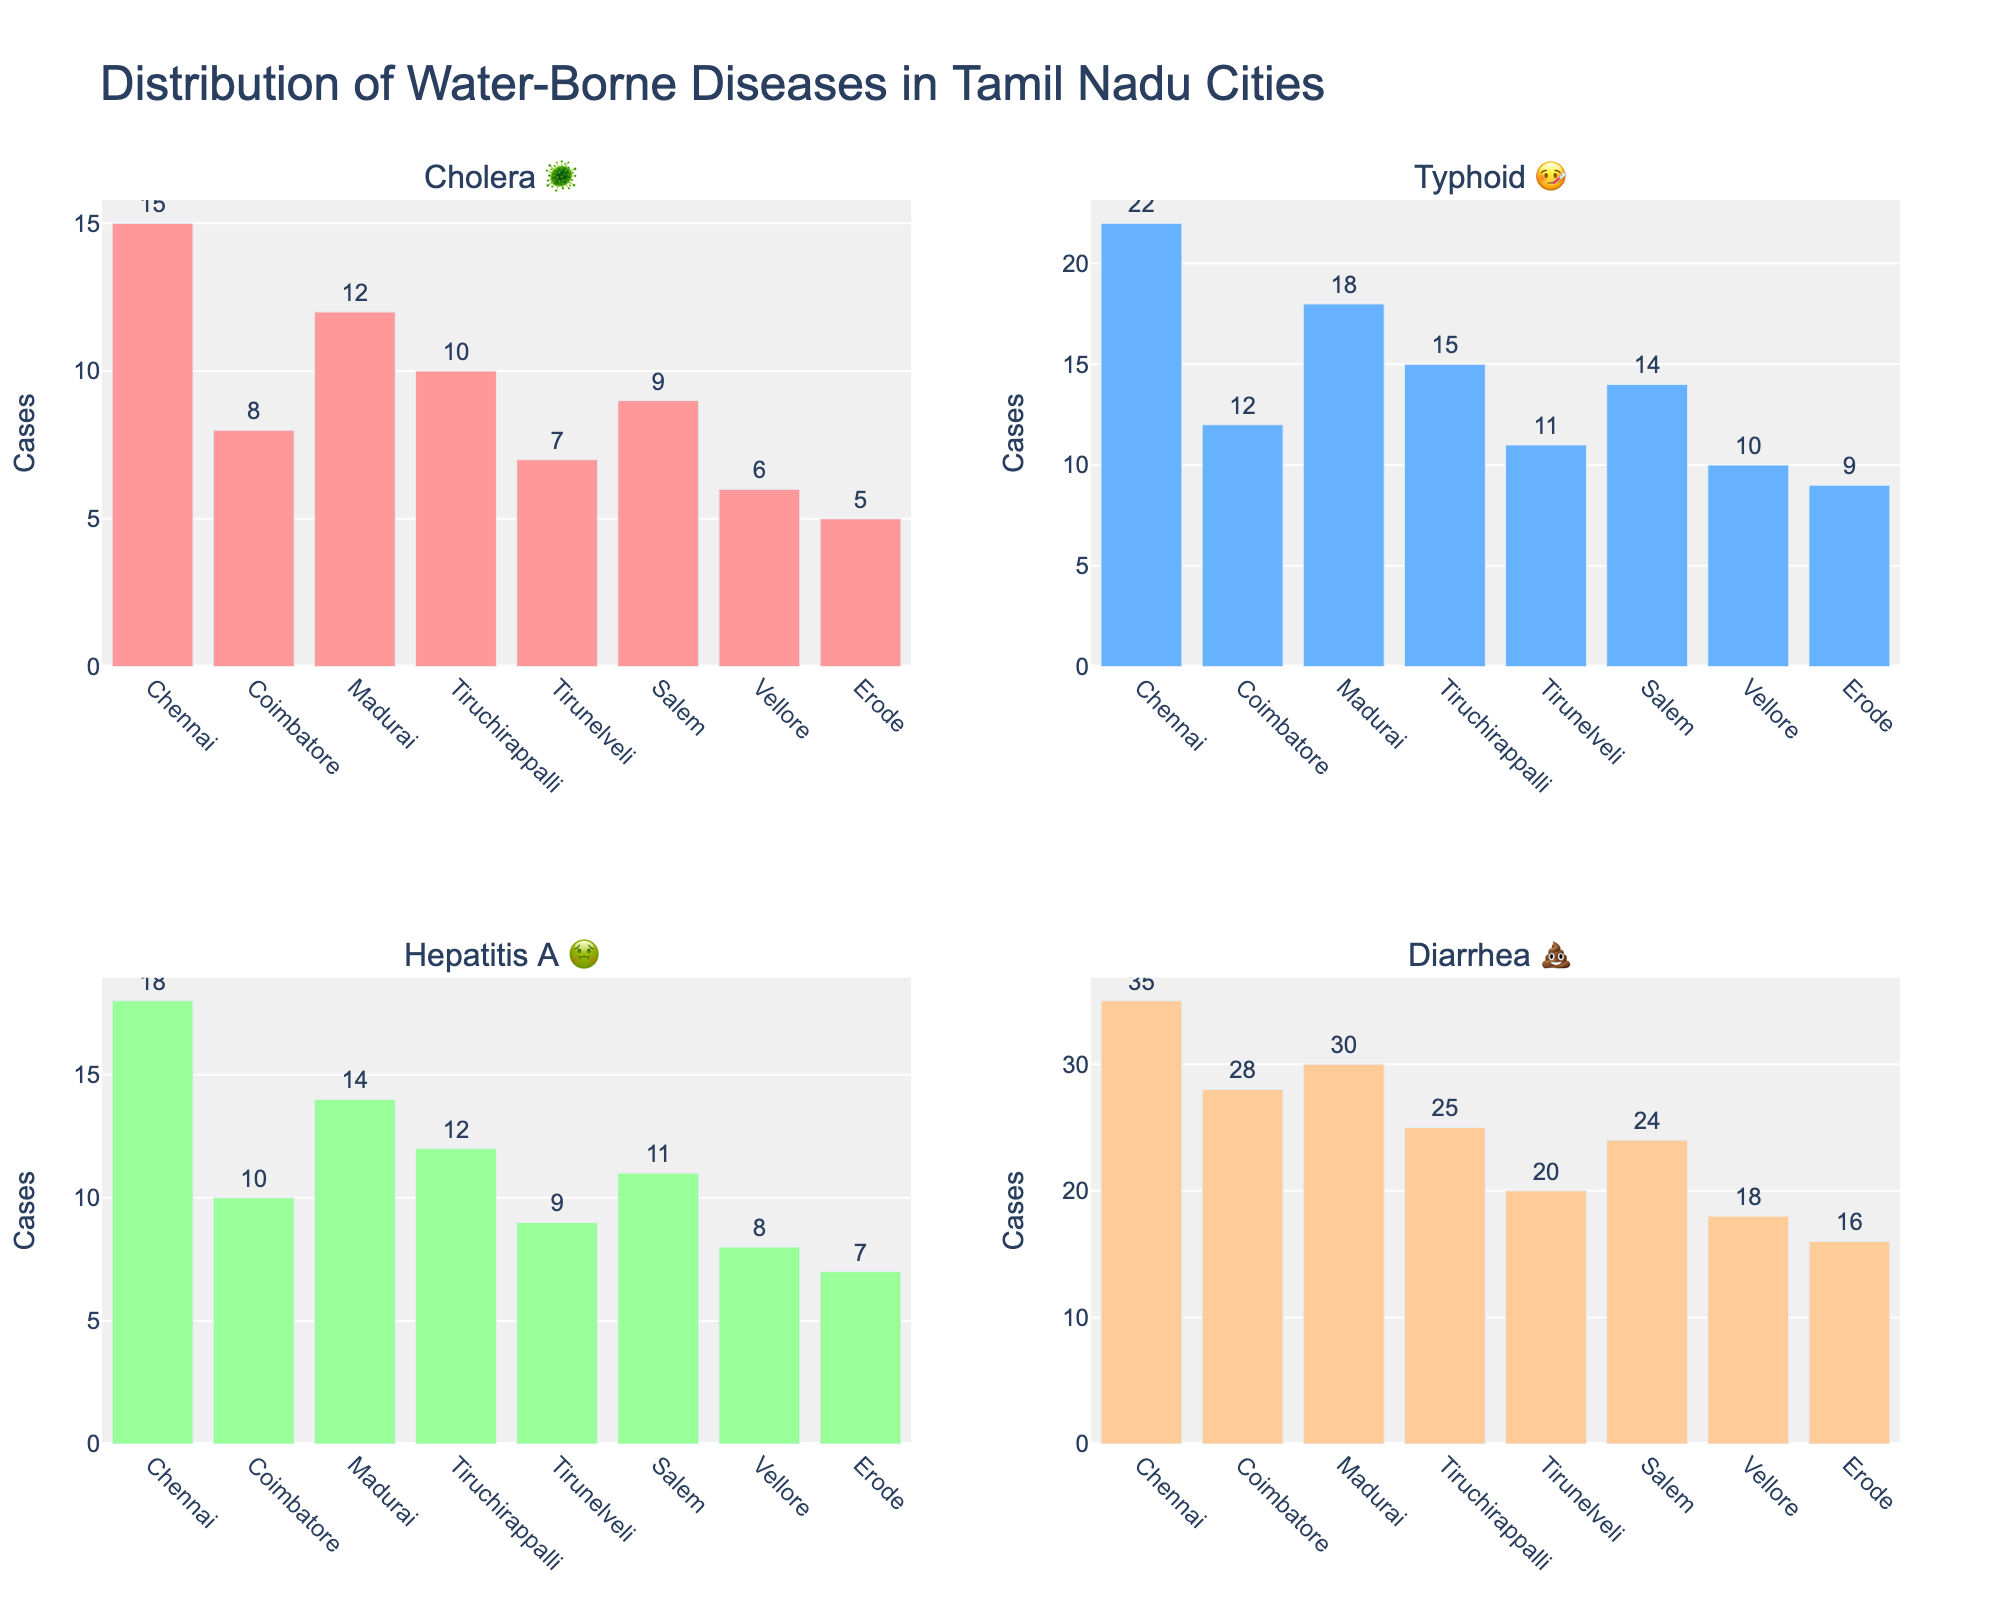What is the title of the chart? The chart title is prominently displayed at the top and reads "Distribution of Water-Borne Diseases in Tamil Nadu Cities".
Answer: Distribution of Water-Borne Diseases in Tamil Nadu Cities Which city has the highest number of Diarrhea 💩 cases? Look at the subplot for Diarrhea 💩, and observe the city with the highest bar. Chennai has the highest number of cases.
Answer: Chennai How many Cholera 🦠 cases are there in Coimbatore and Erode combined? Look at the Cholera 🦠 subplot and find the bars for Coimbatore and Erode. Add the values together: 8 (Coimbatore) + 5 (Erode) = 13.
Answer: 13 Which disease has the lowest number of cases in Vellore? Observe the bars for Vellore across all subplots. The shortest bar corresponds to the disease with the lowest number of cases, which is Hepatitis A 🤢, with 8 cases.
Answer: Hepatitis A 🤢 Compare the number of Typhoid 🤒 cases in Chennai and Madurai. Which city has more, and by how many? Look at the Typhoid 🤒 subplot and compare the bar heights for Chennai and Madurai. Chennai has 22 cases, and Madurai has 18 cases. The difference is 22 - 18 = 4.
Answer: Chennai has 4 more cases What is the total number of water-borne disease cases in Tirunelveli? Add the values of all diseases in Tirunelveli: 7 (Cholera 🦠) + 11 (Typhoid 🤒) + 9 (Hepatitis A 🤢) + 20 (Diarrhea 💩) = 47.
Answer: 47 Which disease has the highest total number of cases across all cities? Sum the values for each disease across all cities and compare. Diarrhea 💩 has the highest total: 35+28+30+25+20+24+18+16 = 196.
Answer: Diarrhea 💩 How many Hepatitis A 🤢 cases are there in Madurai? Look at the Hepatitis A 🤢 subplot and find the bar for Madurai. The number of cases is shown on top of the bar, which is 14.
Answer: 14 Which city has the second highest number of Cholera 🦠 cases? Look at the Cholera 🦠 subplot and rank the cities by bar height. Madurai is second highest, with 12 cases.
Answer: Madurai 